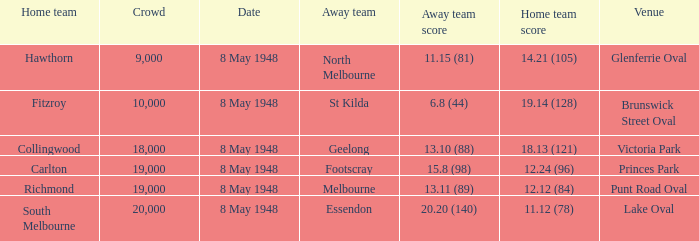Could you parse the entire table as a dict? {'header': ['Home team', 'Crowd', 'Date', 'Away team', 'Away team score', 'Home team score', 'Venue'], 'rows': [['Hawthorn', '9,000', '8 May 1948', 'North Melbourne', '11.15 (81)', '14.21 (105)', 'Glenferrie Oval'], ['Fitzroy', '10,000', '8 May 1948', 'St Kilda', '6.8 (44)', '19.14 (128)', 'Brunswick Street Oval'], ['Collingwood', '18,000', '8 May 1948', 'Geelong', '13.10 (88)', '18.13 (121)', 'Victoria Park'], ['Carlton', '19,000', '8 May 1948', 'Footscray', '15.8 (98)', '12.24 (96)', 'Princes Park'], ['Richmond', '19,000', '8 May 1948', 'Melbourne', '13.11 (89)', '12.12 (84)', 'Punt Road Oval'], ['South Melbourne', '20,000', '8 May 1948', 'Essendon', '20.20 (140)', '11.12 (78)', 'Lake Oval']]} Which away team has a home score of 14.21 (105)? North Melbourne. 